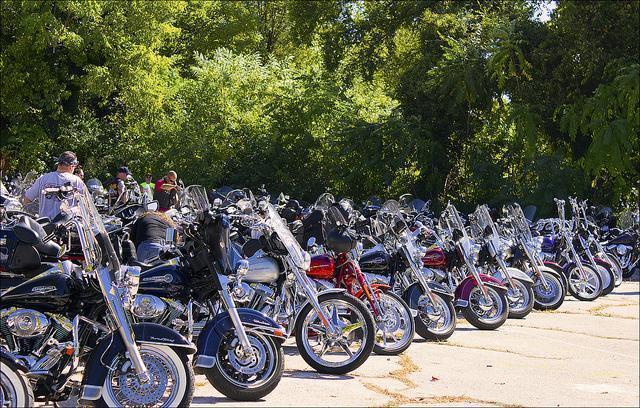Which direction are all the front wheels facing?
Choose the right answer from the provided options to respond to the question.
Options: Sideways, right, straight, left. Left. 